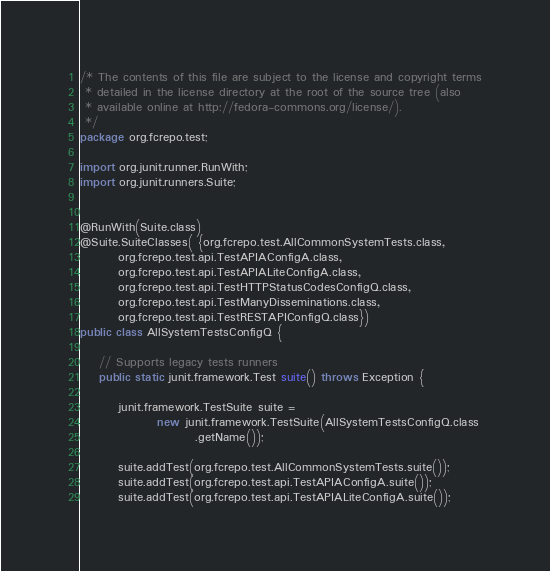Convert code to text. <code><loc_0><loc_0><loc_500><loc_500><_Java_>/* The contents of this file are subject to the license and copyright terms
 * detailed in the license directory at the root of the source tree (also
 * available online at http://fedora-commons.org/license/).
 */
package org.fcrepo.test;

import org.junit.runner.RunWith;
import org.junit.runners.Suite;


@RunWith(Suite.class)
@Suite.SuiteClasses( {org.fcrepo.test.AllCommonSystemTests.class,
        org.fcrepo.test.api.TestAPIAConfigA.class,
        org.fcrepo.test.api.TestAPIALiteConfigA.class,
        org.fcrepo.test.api.TestHTTPStatusCodesConfigQ.class,
        org.fcrepo.test.api.TestManyDisseminations.class,
        org.fcrepo.test.api.TestRESTAPIConfigQ.class})
public class AllSystemTestsConfigQ {

    // Supports legacy tests runners
    public static junit.framework.Test suite() throws Exception {

        junit.framework.TestSuite suite =
                new junit.framework.TestSuite(AllSystemTestsConfigQ.class
                        .getName());

        suite.addTest(org.fcrepo.test.AllCommonSystemTests.suite());
        suite.addTest(org.fcrepo.test.api.TestAPIAConfigA.suite());
        suite.addTest(org.fcrepo.test.api.TestAPIALiteConfigA.suite());</code> 